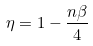Convert formula to latex. <formula><loc_0><loc_0><loc_500><loc_500>\eta = 1 - \frac { n \beta } { 4 }</formula> 